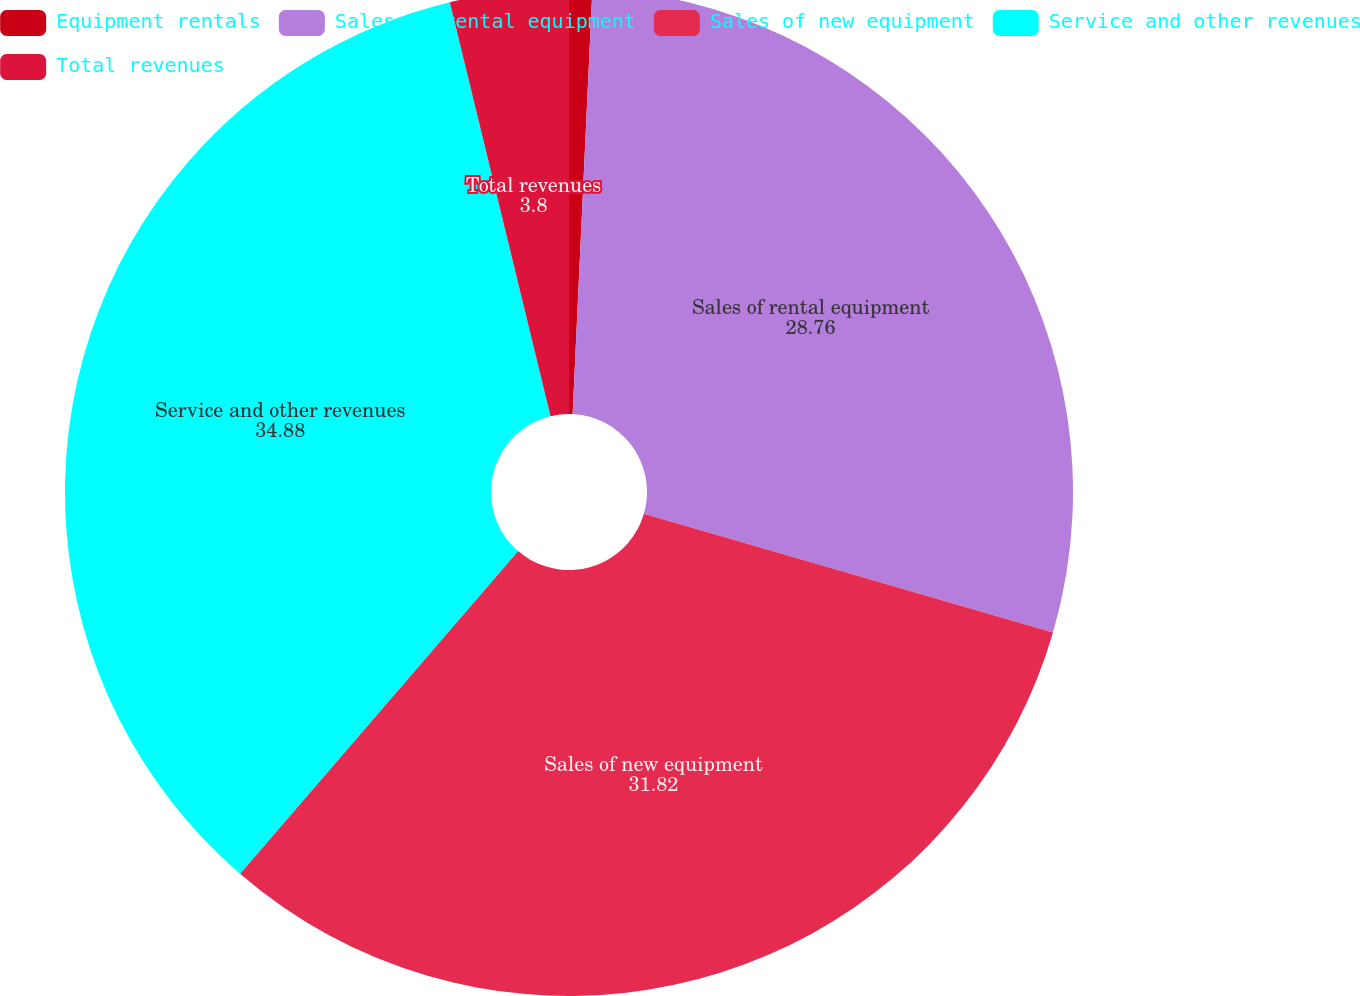Convert chart. <chart><loc_0><loc_0><loc_500><loc_500><pie_chart><fcel>Equipment rentals<fcel>Sales of rental equipment<fcel>Sales of new equipment<fcel>Service and other revenues<fcel>Total revenues<nl><fcel>0.74%<fcel>28.76%<fcel>31.82%<fcel>34.88%<fcel>3.8%<nl></chart> 